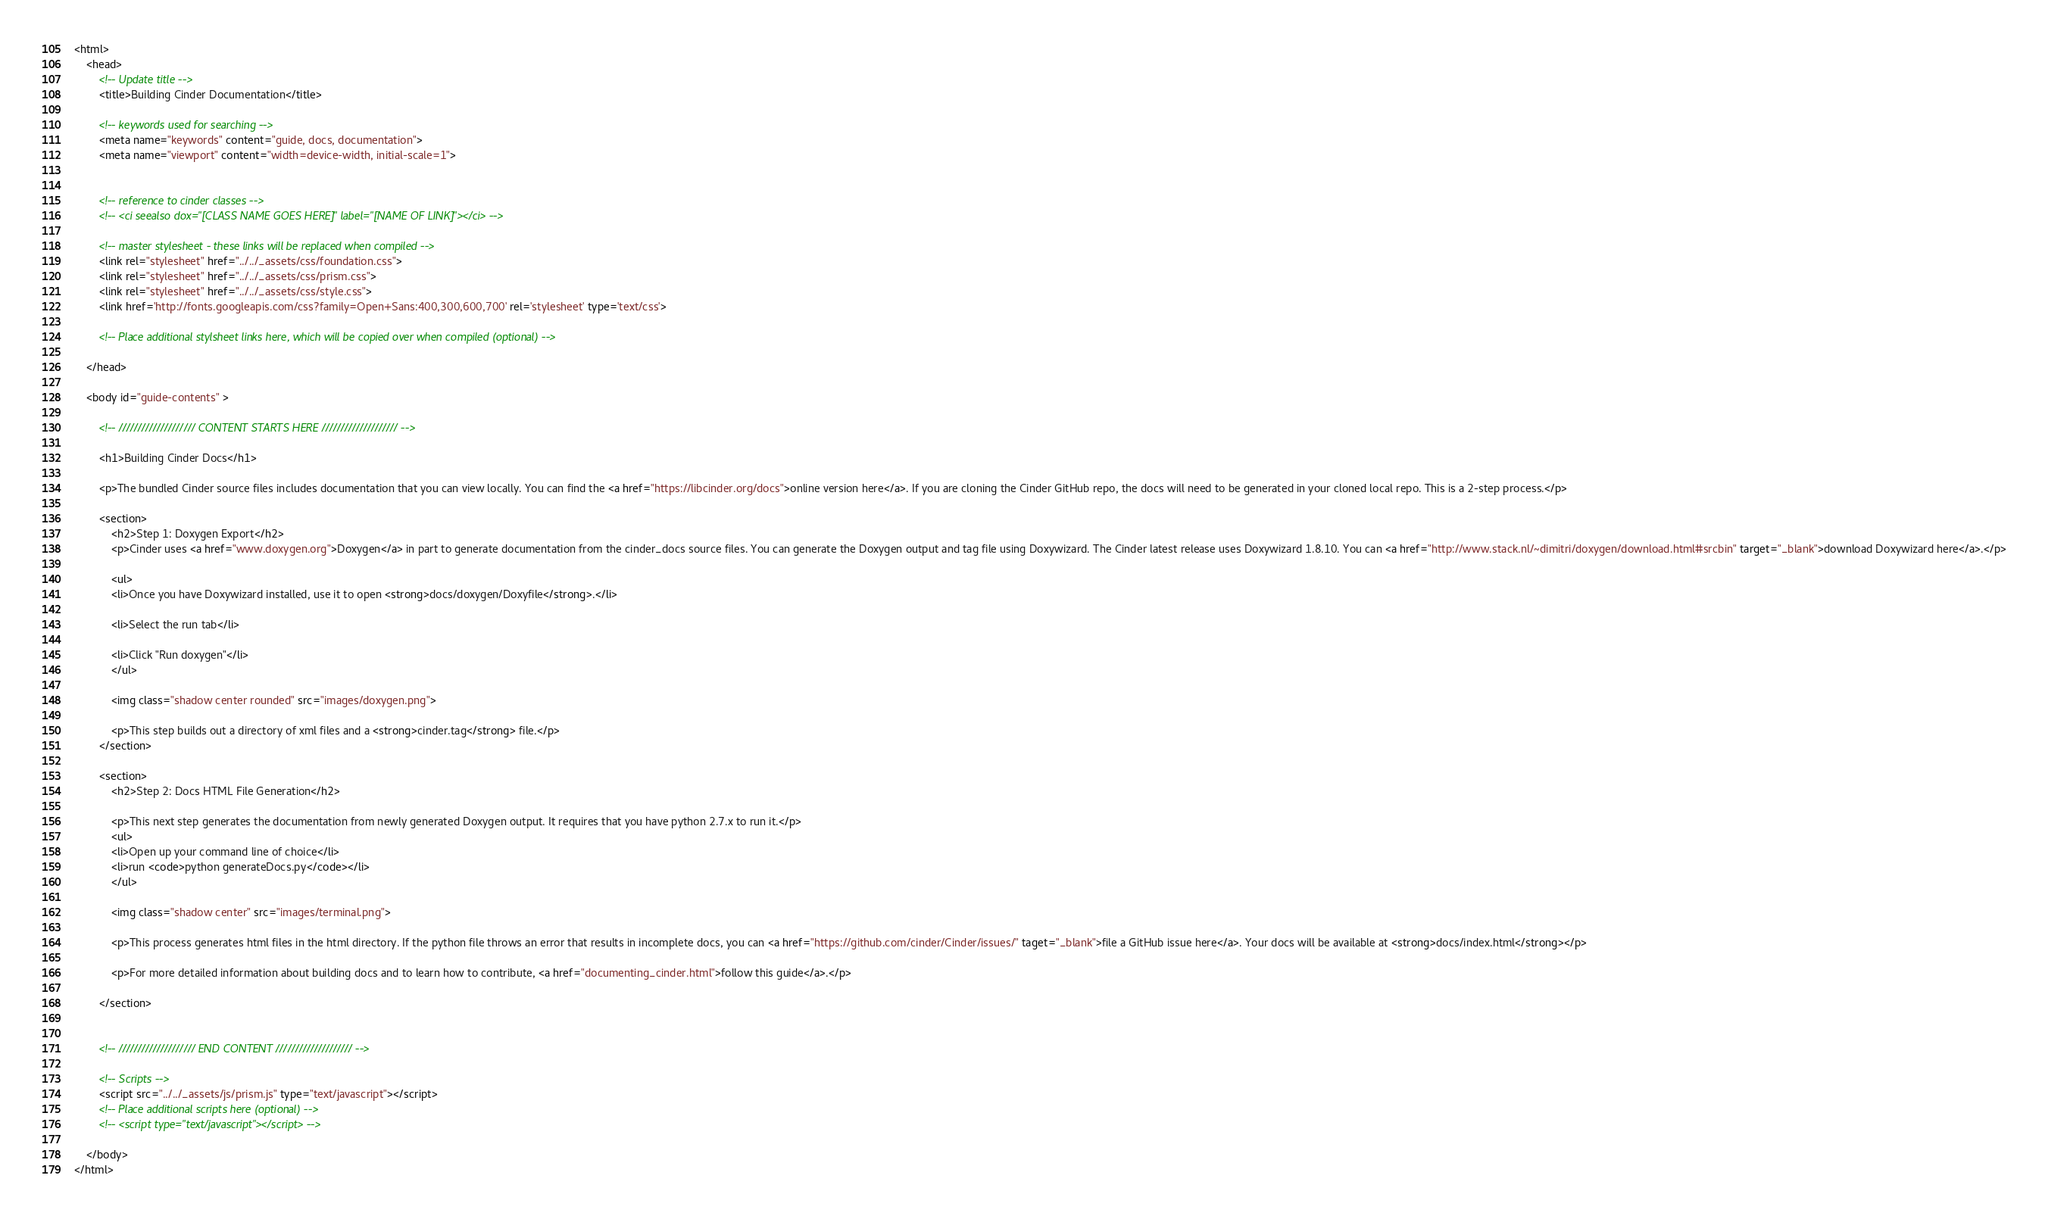<code> <loc_0><loc_0><loc_500><loc_500><_HTML_><html>
	<head>
		<!-- Update title -->
		<title>Building Cinder Documentation</title>

		<!-- keywords used for searching -->
		<meta name="keywords" content="guide, docs, documentation">
		<meta name="viewport" content="width=device-width, initial-scale=1">


		<!-- reference to cinder classes -->
   		<!-- <ci seealso dox="[CLASS NAME GOES HERE]" label="[NAME OF LINK]"></ci> -->

   		<!-- master stylesheet - these links will be replaced when compiled -->
		<link rel="stylesheet" href="../../_assets/css/foundation.css">
		<link rel="stylesheet" href="../../_assets/css/prism.css">
		<link rel="stylesheet" href="../../_assets/css/style.css">
		<link href='http://fonts.googleapis.com/css?family=Open+Sans:400,300,600,700' rel='stylesheet' type='text/css'>

		<!-- Place additional stylsheet links here, which will be copied over when compiled (optional) -->
		
	</head>

	<body id="guide-contents" >

		<!-- //////////////////// CONTENT STARTS HERE //////////////////// -->

		<h1>Building Cinder Docs</h1>
		
		<p>The bundled Cinder source files includes documentation that you can view locally. You can find the <a href="https://libcinder.org/docs">online version here</a>. If you are cloning the Cinder GitHub repo, the docs will need to be generated in your cloned local repo. This is a 2-step process.</p>

		<section>
			<h2>Step 1: Doxygen Export</h2>
			<p>Cinder uses <a href="www.doxygen.org">Doxygen</a> in part to generate documentation from the cinder_docs source files. You can generate the Doxygen output and tag file using Doxywizard. The Cinder latest release uses Doxywizard 1.8.10. You can <a href="http://www.stack.nl/~dimitri/doxygen/download.html#srcbin" target="_blank">download Doxywizard here</a>.</p>
			
			<ul>
			<li>Once you have Doxywizard installed, use it to open <strong>docs/doxygen/Doxyfile</strong>.</li>
	
			<li>Select the run tab</li>
	
			<li>Click "Run doxygen"</li>
			</ul>

			<img class="shadow center rounded" src="images/doxygen.png">
	
			<p>This step builds out a directory of xml files and a <strong>cinder.tag</strong> file.</p>
		</section>

		<section>
			<h2>Step 2: Docs HTML File Generation</h2>

			<p>This next step generates the documentation from newly generated Doxygen output. It requires that you have python 2.7.x to run it.</p>
			<ul>
			<li>Open up your command line of choice</li>
			<li>run <code>python generateDocs.py</code></li>
			</ul>
				
			<img class="shadow center" src="images/terminal.png">

			<p>This process generates html files in the html directory. If the python file throws an error that results in incomplete docs, you can <a href="https://github.com/cinder/Cinder/issues/" taget="_blank">file a GitHub issue here</a>. Your docs will be available at <strong>docs/index.html</strong></p>

			<p>For more detailed information about building docs and to learn how to contribute, <a href="documenting_cinder.html">follow this guide</a>.</p>

		</section>

		
		<!-- //////////////////// END CONTENT //////////////////// -->

		<!-- Scripts -->
		<script src="../../_assets/js/prism.js" type="text/javascript"></script>
		<!-- Place additional scripts here (optional) -->
		<!-- <script type="text/javascript"></script> -->

	</body>
</html> </code> 